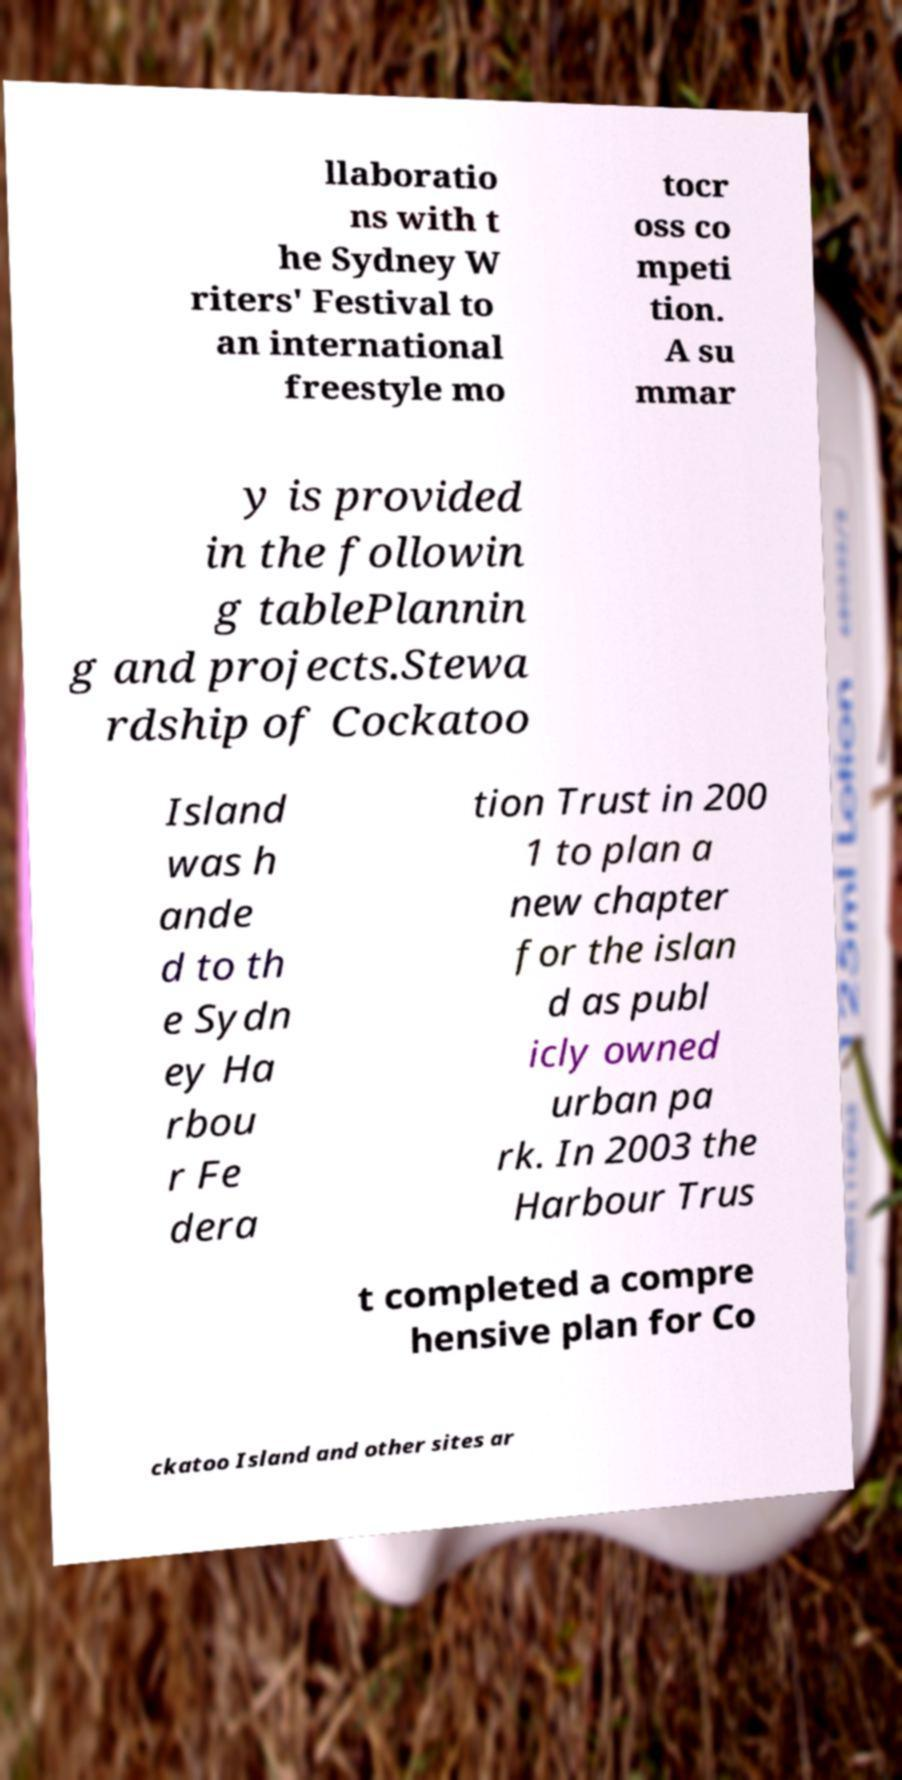Could you assist in decoding the text presented in this image and type it out clearly? llaboratio ns with t he Sydney W riters' Festival to an international freestyle mo tocr oss co mpeti tion. A su mmar y is provided in the followin g tablePlannin g and projects.Stewa rdship of Cockatoo Island was h ande d to th e Sydn ey Ha rbou r Fe dera tion Trust in 200 1 to plan a new chapter for the islan d as publ icly owned urban pa rk. In 2003 the Harbour Trus t completed a compre hensive plan for Co ckatoo Island and other sites ar 